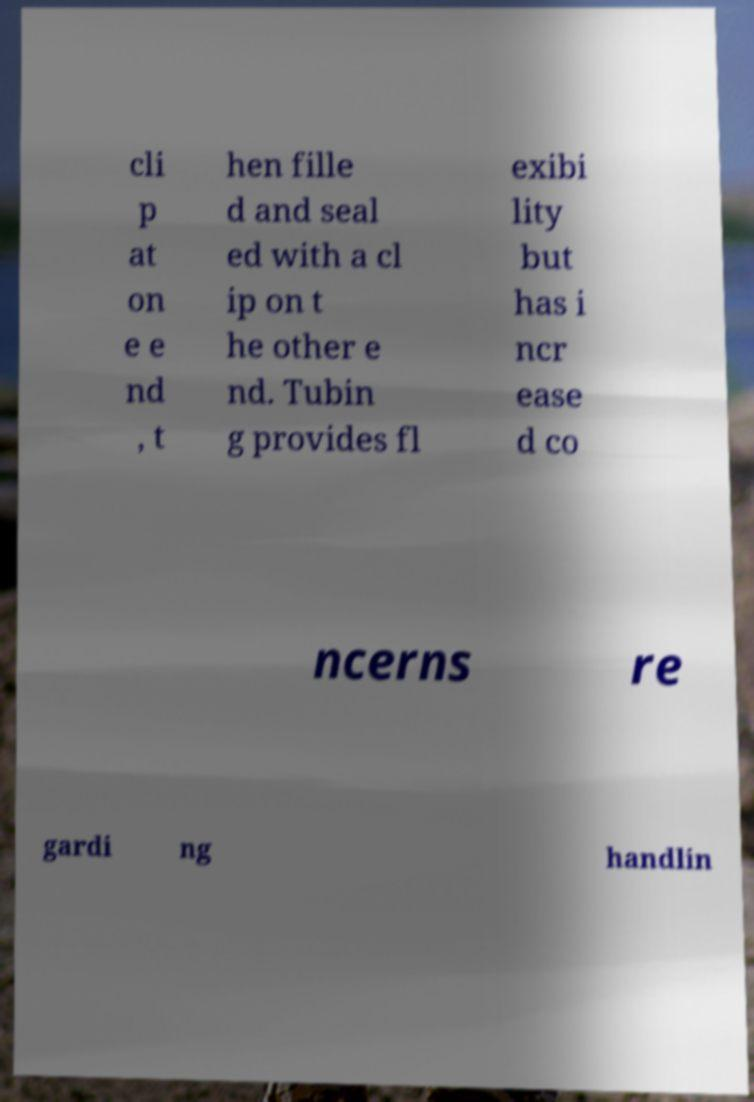Please identify and transcribe the text found in this image. cli p at on e e nd , t hen fille d and seal ed with a cl ip on t he other e nd. Tubin g provides fl exibi lity but has i ncr ease d co ncerns re gardi ng handlin 